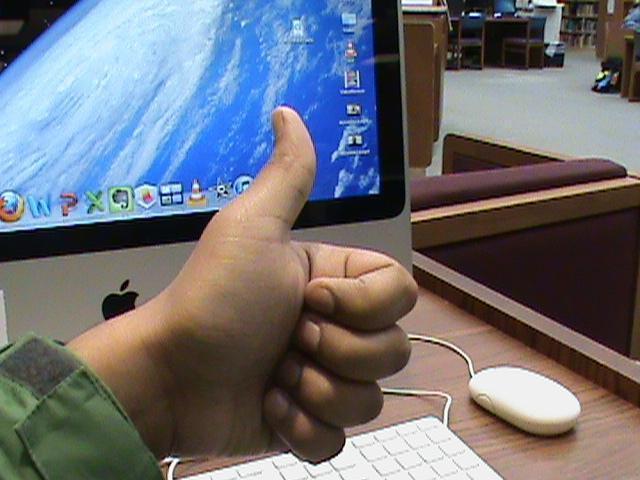How many people are visible?
Give a very brief answer. 1. How many red cars can be seen to the right of the bus?
Give a very brief answer. 0. 